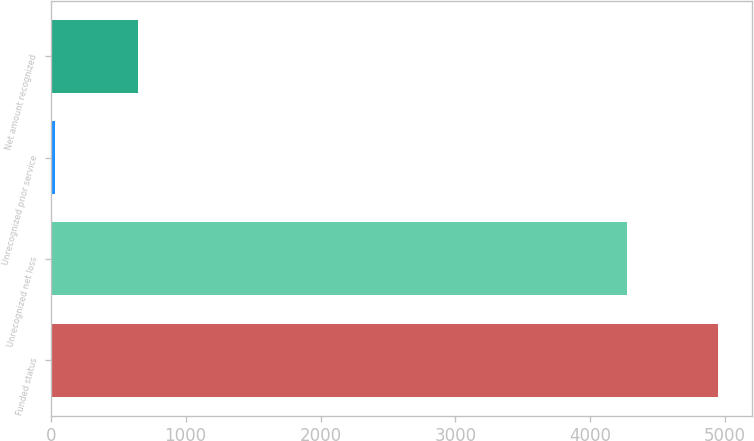<chart> <loc_0><loc_0><loc_500><loc_500><bar_chart><fcel>Funded status<fcel>Unrecognized net loss<fcel>Unrecognized prior service<fcel>Net amount recognized<nl><fcel>4949<fcel>4271<fcel>28<fcel>650<nl></chart> 